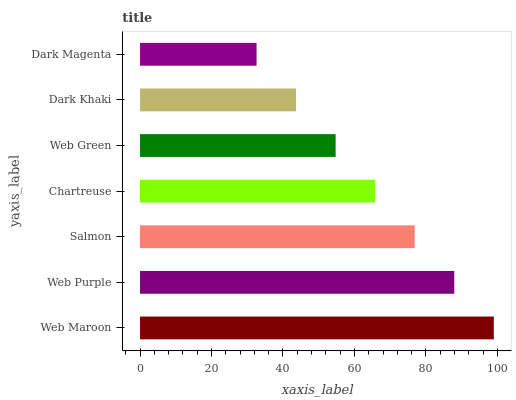Is Dark Magenta the minimum?
Answer yes or no. Yes. Is Web Maroon the maximum?
Answer yes or no. Yes. Is Web Purple the minimum?
Answer yes or no. No. Is Web Purple the maximum?
Answer yes or no. No. Is Web Maroon greater than Web Purple?
Answer yes or no. Yes. Is Web Purple less than Web Maroon?
Answer yes or no. Yes. Is Web Purple greater than Web Maroon?
Answer yes or no. No. Is Web Maroon less than Web Purple?
Answer yes or no. No. Is Chartreuse the high median?
Answer yes or no. Yes. Is Chartreuse the low median?
Answer yes or no. Yes. Is Dark Magenta the high median?
Answer yes or no. No. Is Web Purple the low median?
Answer yes or no. No. 